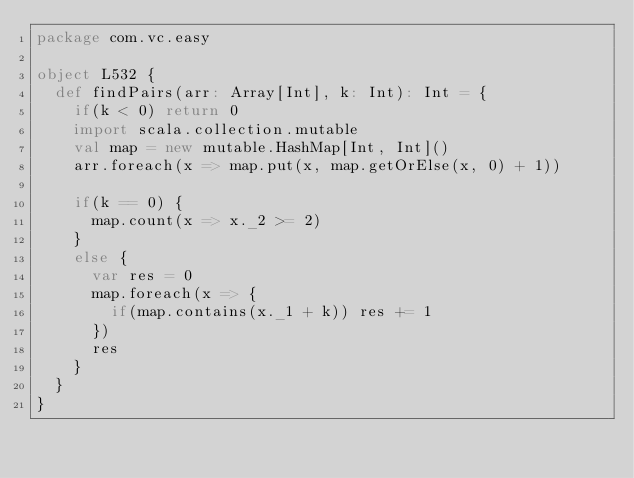Convert code to text. <code><loc_0><loc_0><loc_500><loc_500><_Scala_>package com.vc.easy

object L532 {
  def findPairs(arr: Array[Int], k: Int): Int = {
    if(k < 0) return 0
    import scala.collection.mutable
    val map = new mutable.HashMap[Int, Int]()
    arr.foreach(x => map.put(x, map.getOrElse(x, 0) + 1))

    if(k == 0) {
      map.count(x => x._2 >= 2)
    }
    else {
      var res = 0
      map.foreach(x => {
        if(map.contains(x._1 + k)) res += 1
      })
      res
    }
  }
}
</code> 